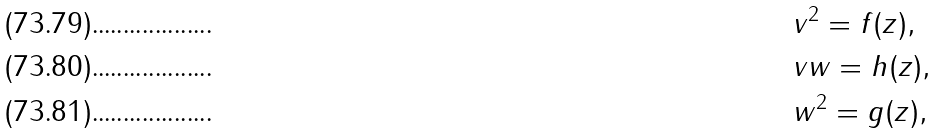<formula> <loc_0><loc_0><loc_500><loc_500>& v ^ { 2 } = f ( z ) , \\ & v w = h ( z ) , \\ & w ^ { 2 } = g ( z ) ,</formula> 